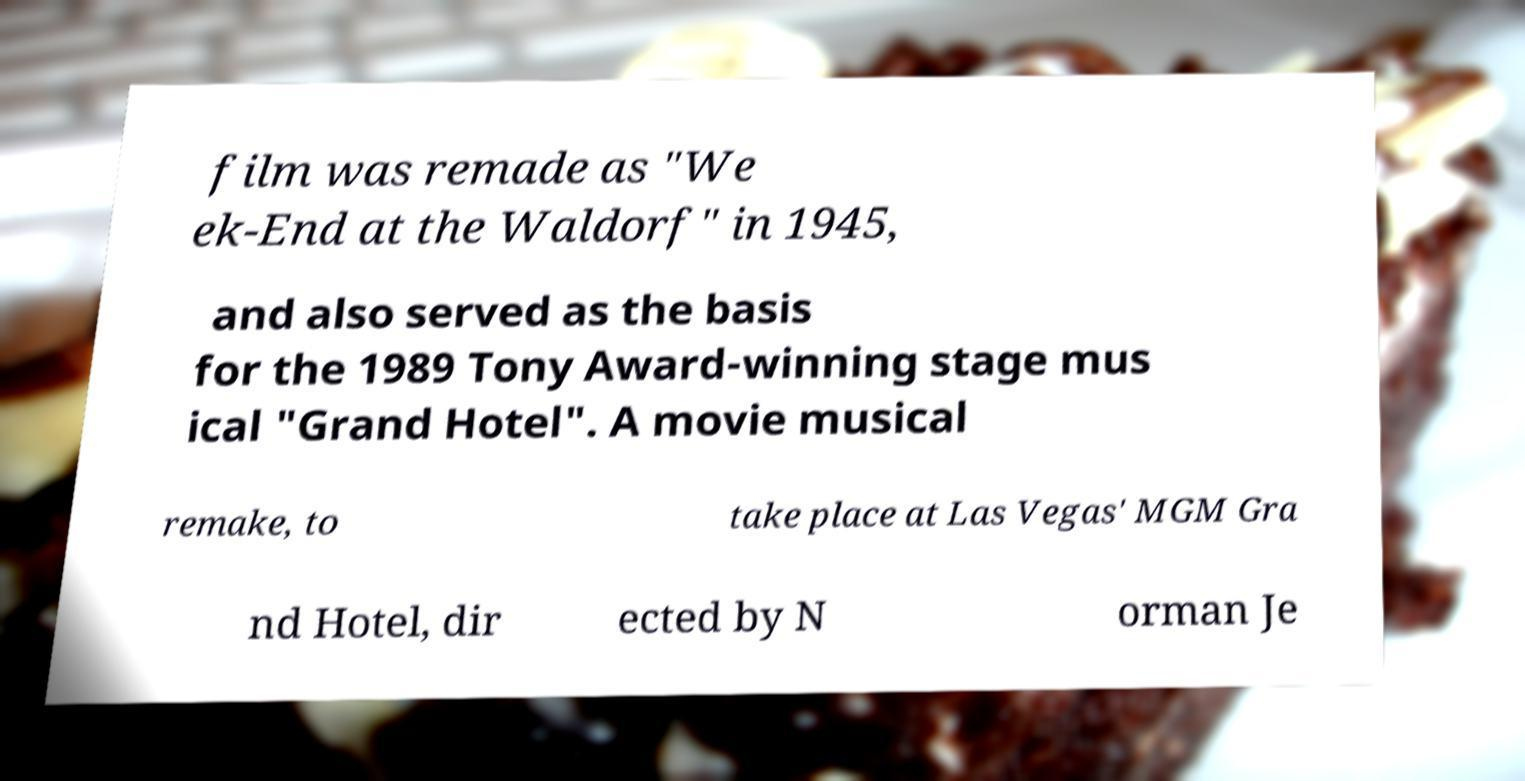Could you extract and type out the text from this image? film was remade as "We ek-End at the Waldorf" in 1945, and also served as the basis for the 1989 Tony Award-winning stage mus ical "Grand Hotel". A movie musical remake, to take place at Las Vegas' MGM Gra nd Hotel, dir ected by N orman Je 